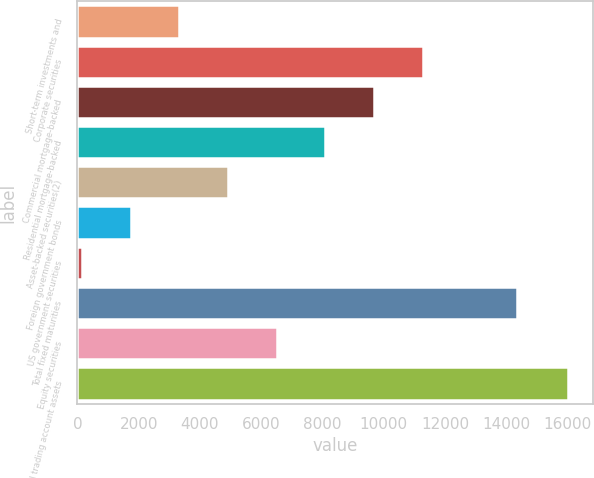<chart> <loc_0><loc_0><loc_500><loc_500><bar_chart><fcel>Short-term investments and<fcel>Corporate securities<fcel>Commercial mortgage-backed<fcel>Residential mortgage-backed<fcel>Asset-backed securities(2)<fcel>Foreign government bonds<fcel>US government securities<fcel>Total fixed maturities<fcel>Equity securities<fcel>Total trading account assets<nl><fcel>3331.2<fcel>11261.7<fcel>9675.6<fcel>8089.5<fcel>4917.3<fcel>1745.1<fcel>159<fcel>14360<fcel>6503.4<fcel>16020<nl></chart> 